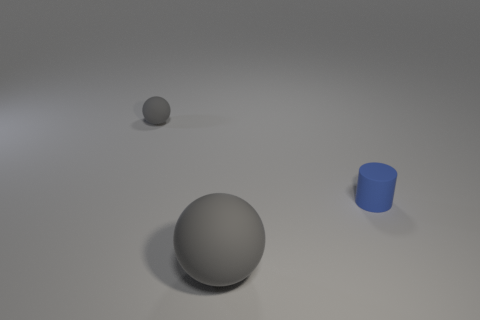There is a tiny rubber object that is the same color as the large sphere; what shape is it?
Give a very brief answer. Sphere. What number of large gray spheres are there?
Your response must be concise. 1. What number of cylinders are big purple things or matte things?
Provide a succinct answer. 1. There is a ball that is the same size as the blue matte cylinder; what color is it?
Offer a very short reply. Gray. How many things are left of the tiny blue matte cylinder and behind the large gray object?
Your response must be concise. 1. What material is the cylinder?
Your response must be concise. Rubber. What number of objects are small cylinders or large purple matte cylinders?
Your response must be concise. 1. There is a matte sphere behind the small blue cylinder; is its size the same as the rubber ball in front of the cylinder?
Ensure brevity in your answer.  No. How many objects are matte balls that are on the right side of the tiny gray ball or things behind the large rubber thing?
Your answer should be compact. 3. Are the large gray ball and the sphere to the left of the large gray rubber sphere made of the same material?
Your answer should be very brief. Yes. 